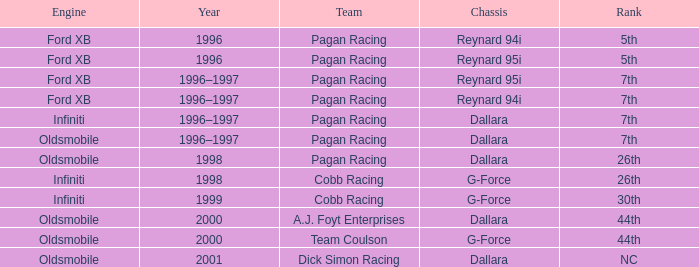In 1996, what was the ranking of the chassis reynard 94i? 5th. 